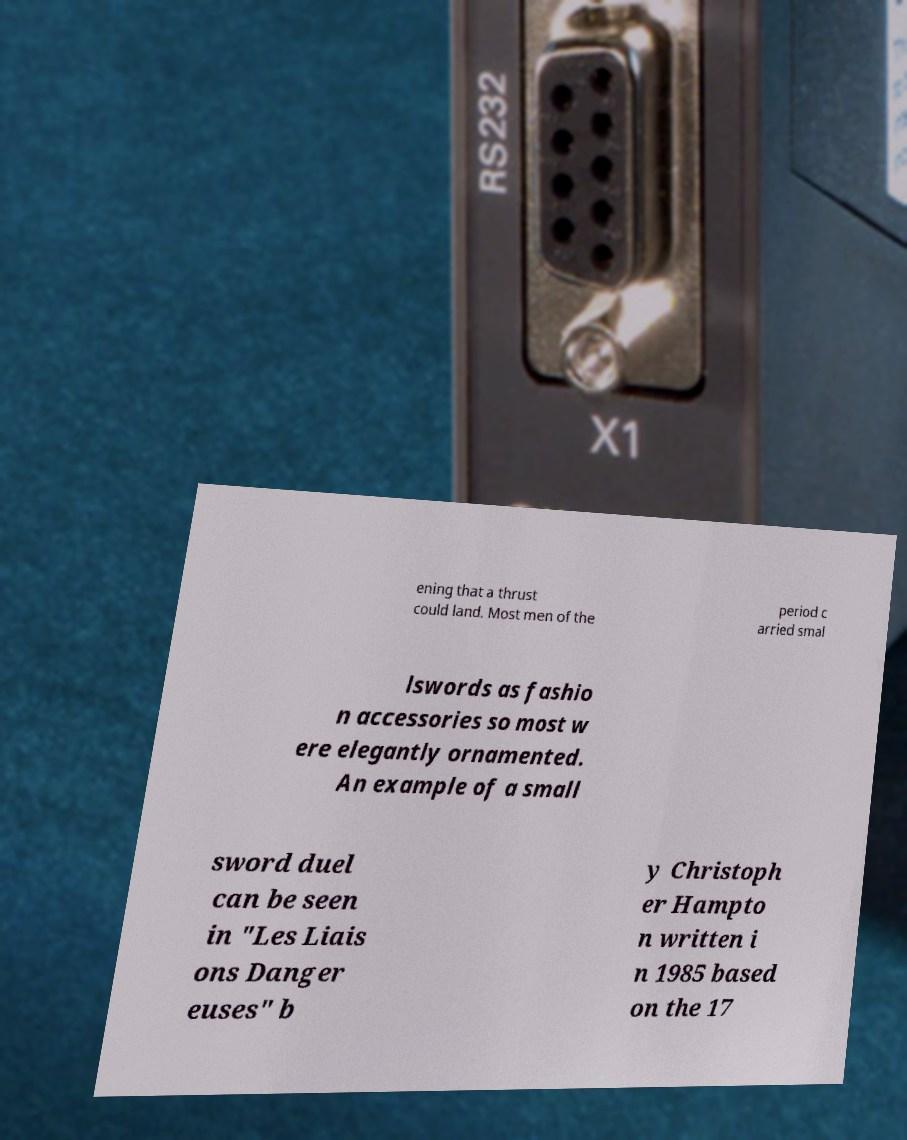What messages or text are displayed in this image? I need them in a readable, typed format. ening that a thrust could land. Most men of the period c arried smal lswords as fashio n accessories so most w ere elegantly ornamented. An example of a small sword duel can be seen in "Les Liais ons Danger euses" b y Christoph er Hampto n written i n 1985 based on the 17 